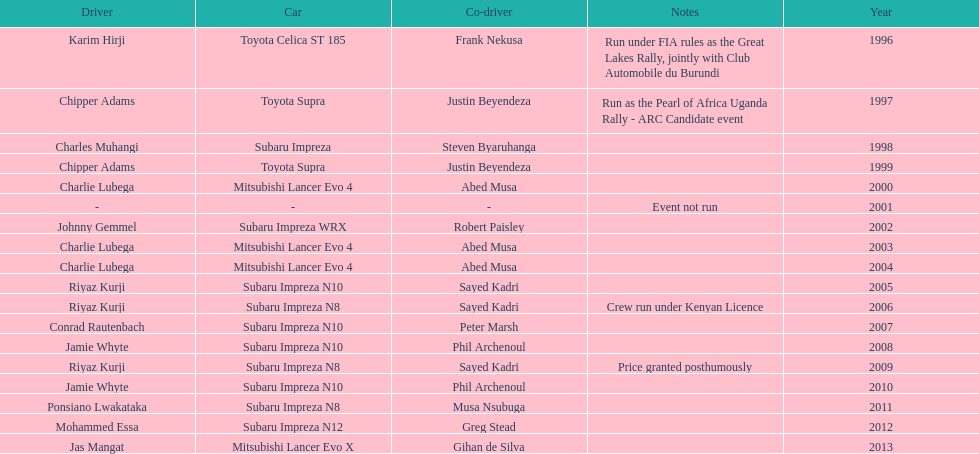Who is the only driver to have consecutive wins? Charlie Lubega. 